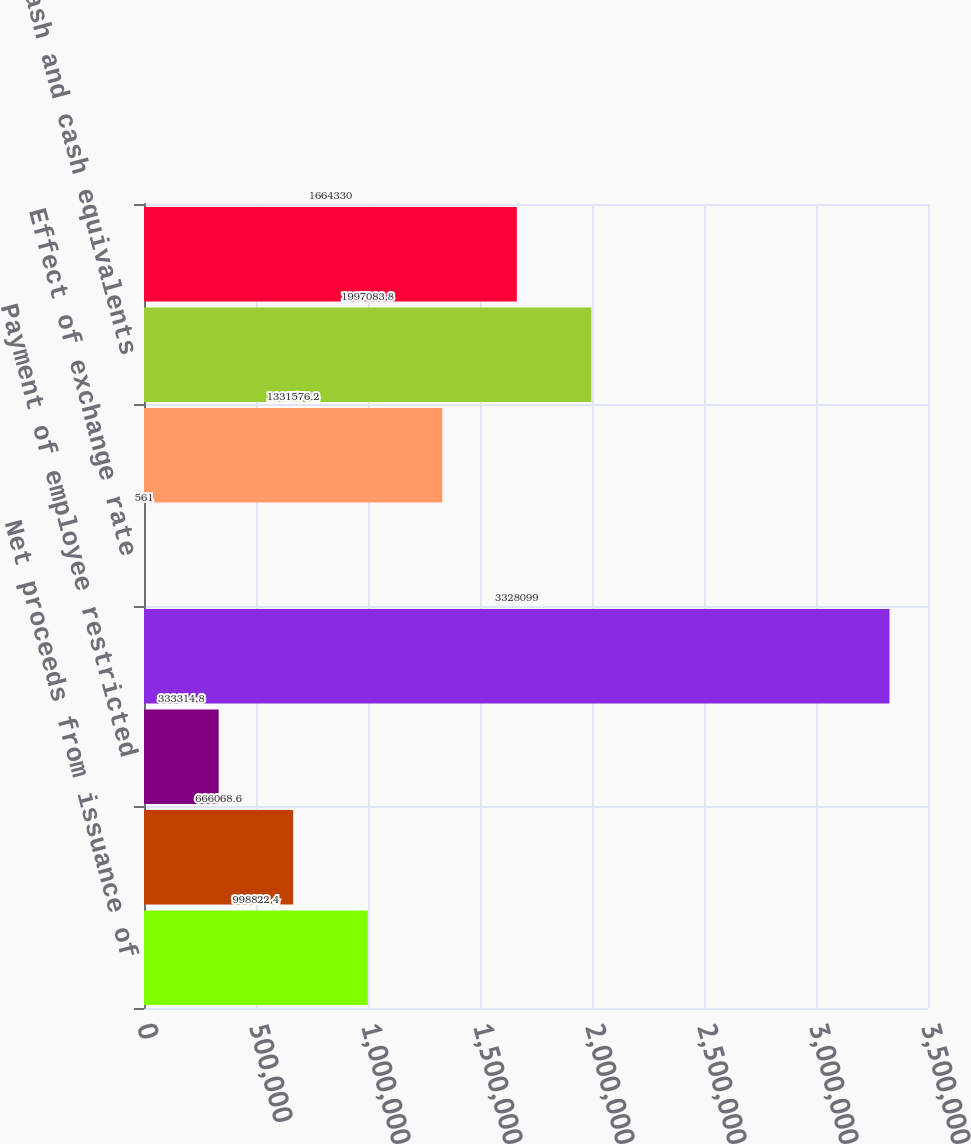Convert chart. <chart><loc_0><loc_0><loc_500><loc_500><bar_chart><fcel>Net proceeds from issuance of<fcel>Excess tax benefit related to<fcel>Payment of employee restricted<fcel>Net cash provided by (used in)<fcel>Effect of exchange rate<fcel>Net increase in cash and cash<fcel>Cash and cash equivalents<fcel>Cash and cash equivalents end<nl><fcel>998822<fcel>666069<fcel>333315<fcel>3.3281e+06<fcel>561<fcel>1.33158e+06<fcel>1.99708e+06<fcel>1.66433e+06<nl></chart> 